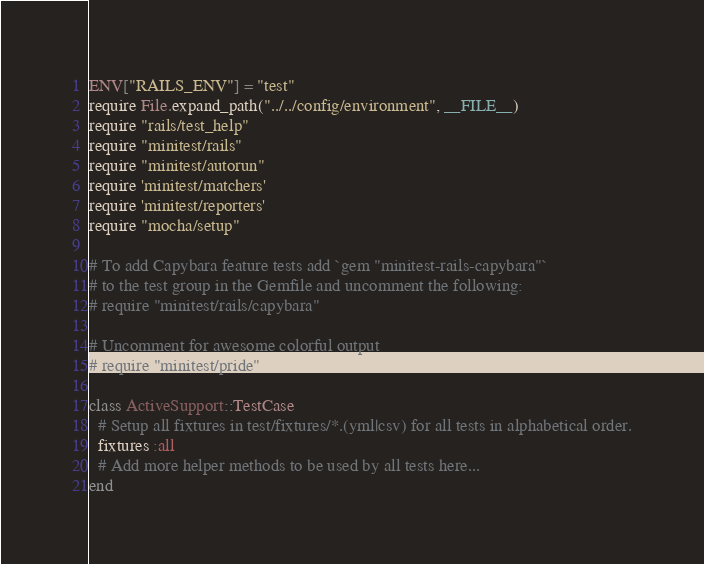<code> <loc_0><loc_0><loc_500><loc_500><_Ruby_>ENV["RAILS_ENV"] = "test"
require File.expand_path("../../config/environment", __FILE__)
require "rails/test_help"
require "minitest/rails"
require "minitest/autorun"
require 'minitest/matchers'
require 'minitest/reporters'
require "mocha/setup"

# To add Capybara feature tests add `gem "minitest-rails-capybara"`
# to the test group in the Gemfile and uncomment the following:
# require "minitest/rails/capybara"

# Uncomment for awesome colorful output
# require "minitest/pride"

class ActiveSupport::TestCase
  # Setup all fixtures in test/fixtures/*.(yml|csv) for all tests in alphabetical order.
  fixtures :all
  # Add more helper methods to be used by all tests here...
end
</code> 